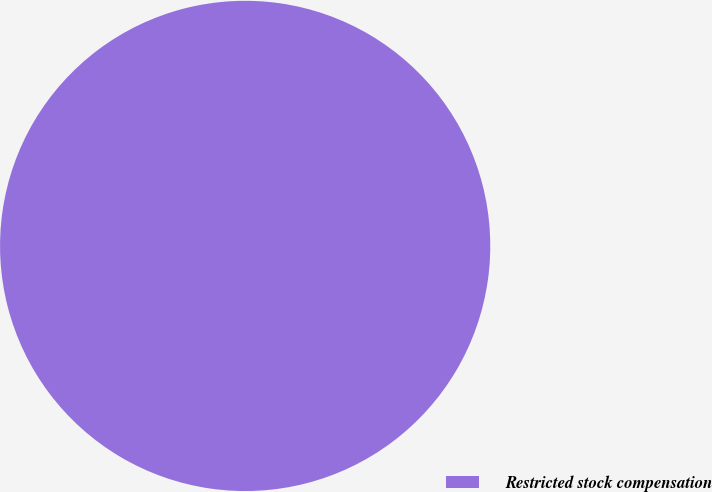<chart> <loc_0><loc_0><loc_500><loc_500><pie_chart><fcel>Restricted stock compensation<nl><fcel>100.0%<nl></chart> 